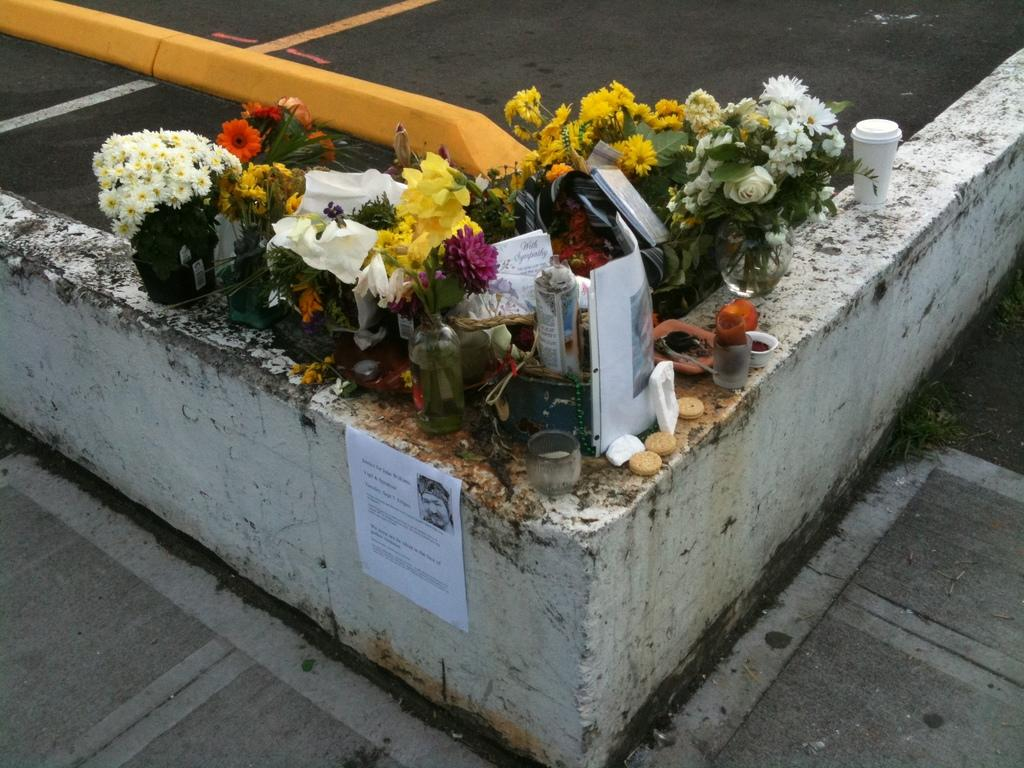What type of containers are present in the image? There are flower vases and flower pots in the image. What type of food items can be seen in the image? There are biscuits in the image. What type of tableware is visible in the image? There are glasses in the image. What type of stationery items are present in the image? There are papers and books in the image. What type of decoration is on the wall in the image? There is a poster on the wall in the image. What type of surface is visible at the bottom of the image? There is a road at the bottom of the image. What type of soda is being served in the glasses in the image? There is no soda present in the image; only glasses are visible. How does the poster on the wall provide support for the books in the image? The poster on the wall does not provide support for the books in the image; it is a separate decoration. What type of material is used to construct the brick wall in the image? There is no brick wall present in the image; only a road is visible at the bottom. 